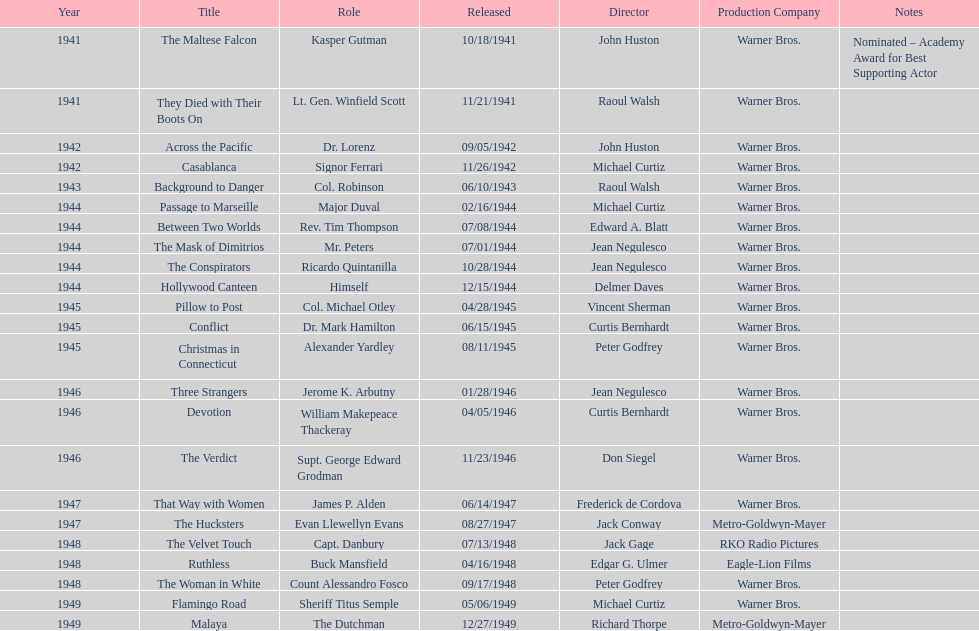What movies did greenstreet act for in 1946? Three Strangers, Devotion, The Verdict. 